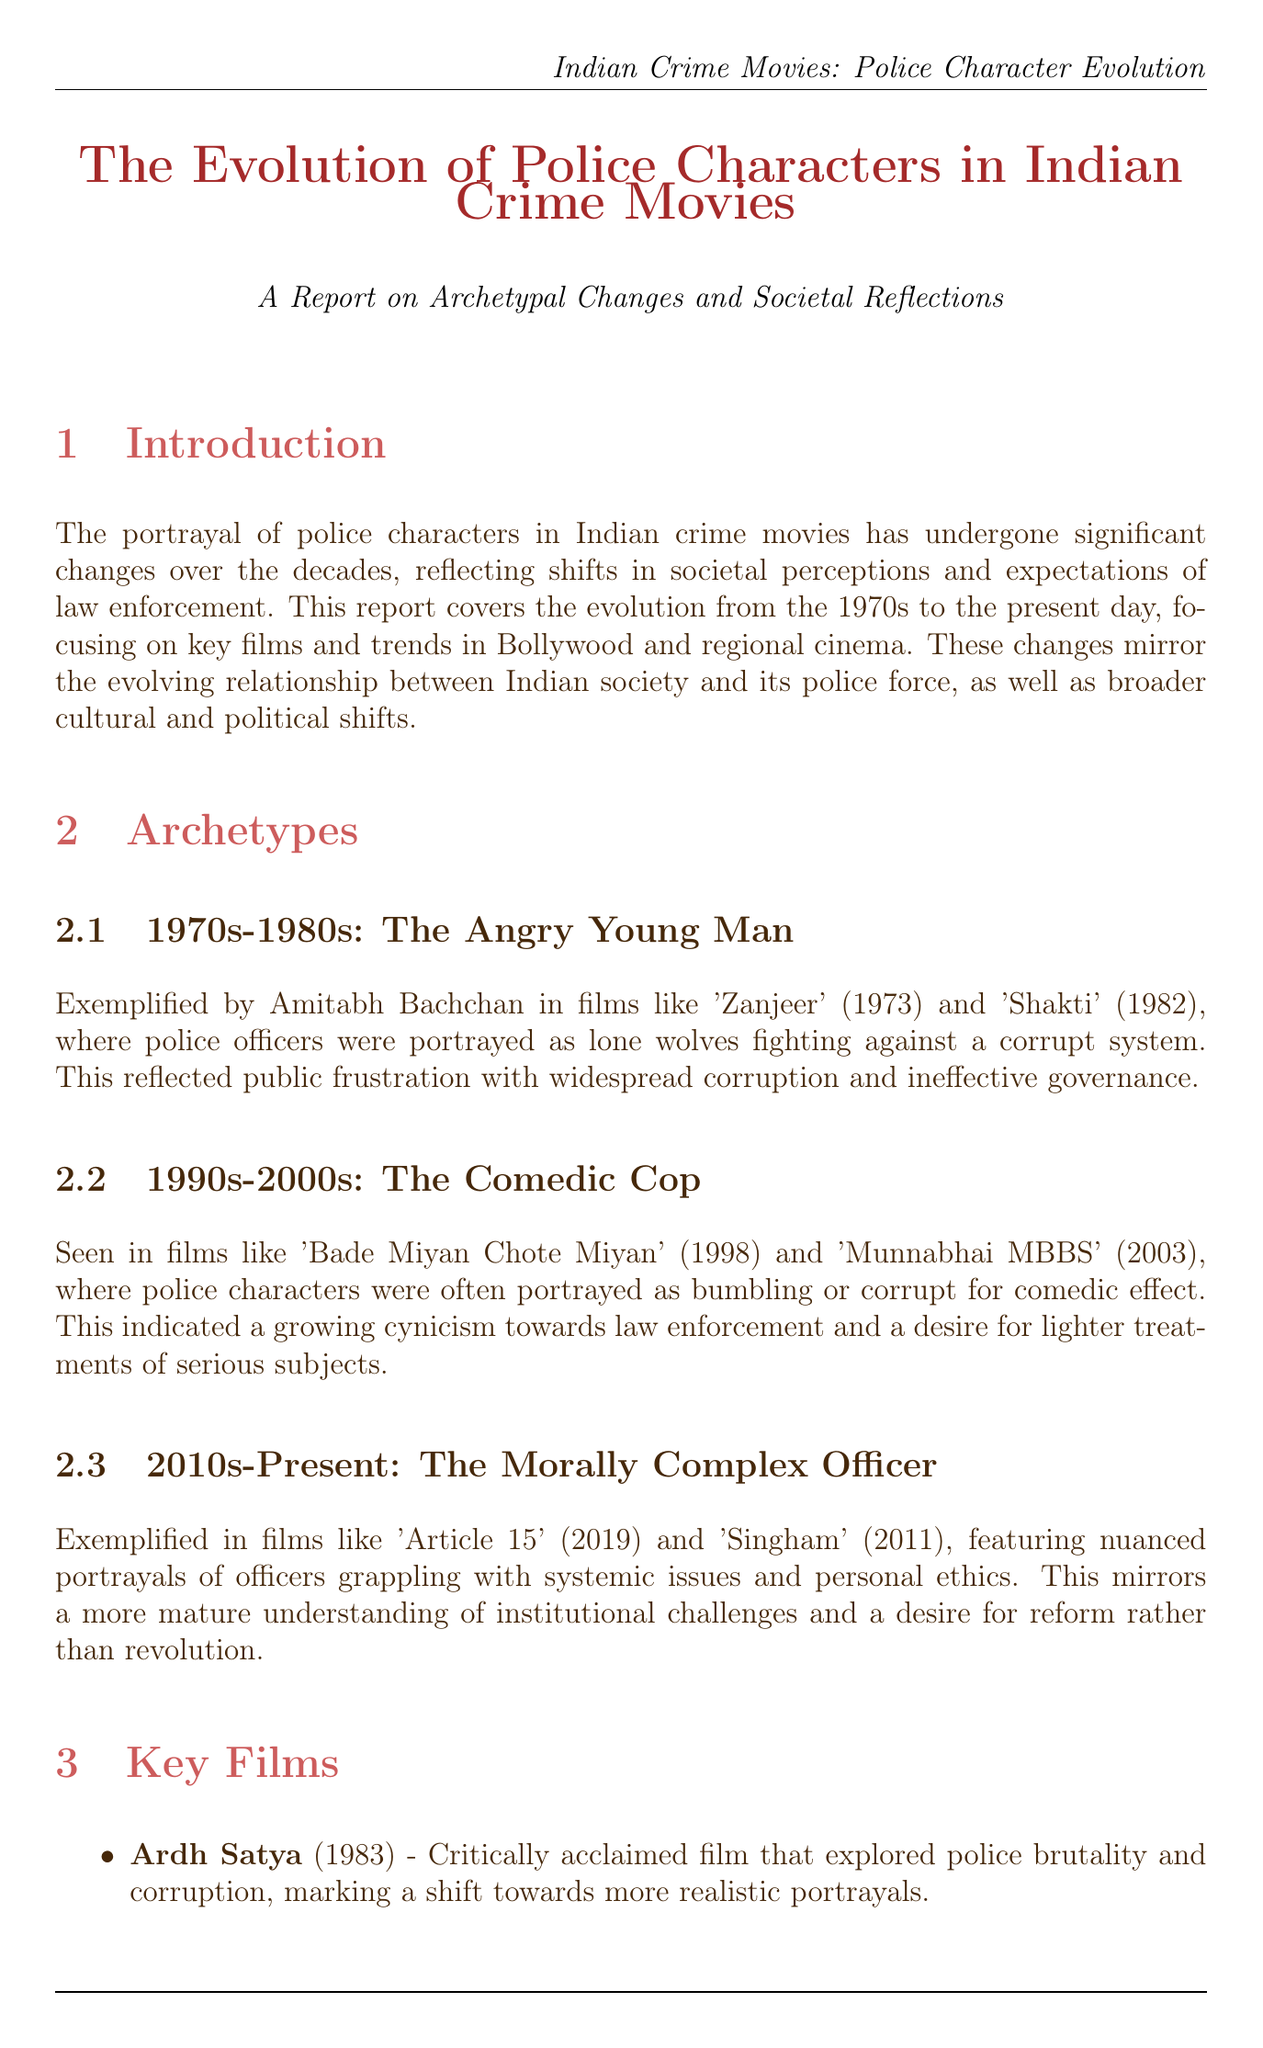What period does the report cover? The report covers the evolution of police characters from the 1970s to the present day.
Answer: 1970s to present day Who is an example of 'The Angry Young Man' archetype? Amitabh Bachchan exemplifies 'The Angry Young Man' archetype in the 1970s-1980s.
Answer: Amitabh Bachchan What film marked a shift towards more realistic portrayals of police? 'Ardh Satya' (1983) explored police brutality and corruption, marking this shift.
Answer: Ardh Satya Which societal factor influenced representations of women in police roles? The Women's Rights Movement influenced the portrayals of strong female police characters.
Answer: Women's Rights Movement What is the significance of 'Gangaajal'? 'Gangaajal' examined police reform and vigilantism, reflecting public desire for swift justice.
Answer: Examined police reform and vigilantism In which decade were comedic cops prevalent? The 1990s-2000s featured comedic portrayals of police characters.
Answer: 1990s-2000s What archetype appears in films like 'Mardaani' and 'Delhi Crime'? Both films feature strong female police characters reflecting changing gender roles.
Answer: Strong female police characters Which regional cinema is known for sophisticated crime thrillers? Tamil cinema is known for its sophisticated crime thrillers, such as 'Vettaiyaadu Vilaiyaadu'.
Answer: Tamil cinema What does the conclusion suggest about future portrayals of police characters? The conclusion suggests continued focus on systemic issues and a more globalized approach.
Answer: Continued focus on systemic issues 